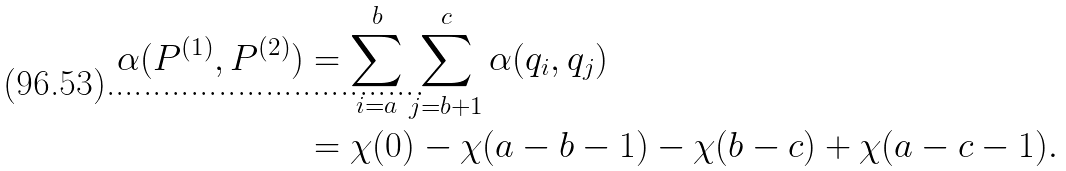Convert formula to latex. <formula><loc_0><loc_0><loc_500><loc_500>\alpha ( P ^ { ( 1 ) } , P ^ { ( 2 ) } ) & = \sum _ { i = a } ^ { b } \sum _ { j = b + 1 } ^ { c } \alpha ( q _ { i } , q _ { j } ) \\ & = \chi ( 0 ) - \chi ( a - b - 1 ) - \chi ( b - c ) + \chi ( a - c - 1 ) .</formula> 